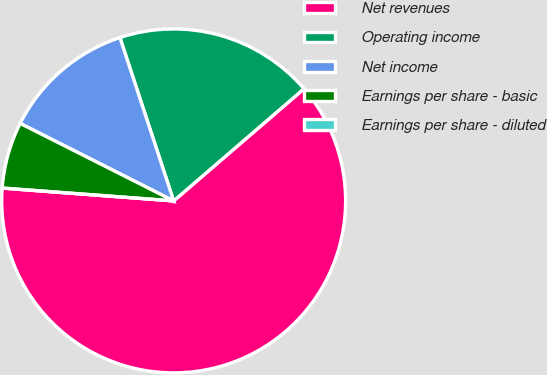<chart> <loc_0><loc_0><loc_500><loc_500><pie_chart><fcel>Net revenues<fcel>Operating income<fcel>Net income<fcel>Earnings per share - basic<fcel>Earnings per share - diluted<nl><fcel>62.5%<fcel>18.75%<fcel>12.5%<fcel>6.25%<fcel>0.0%<nl></chart> 